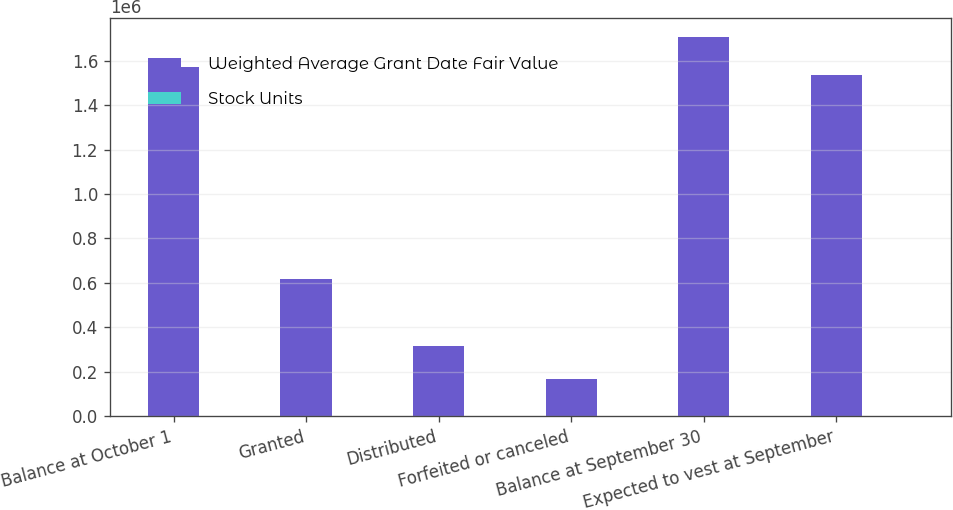Convert chart. <chart><loc_0><loc_0><loc_500><loc_500><stacked_bar_chart><ecel><fcel>Balance at October 1<fcel>Granted<fcel>Distributed<fcel>Forfeited or canceled<fcel>Balance at September 30<fcel>Expected to vest at September<nl><fcel>Weighted Average Grant Date Fair Value<fcel>1.57033e+06<fcel>618679<fcel>316839<fcel>165211<fcel>1.70696e+06<fcel>1.53626e+06<nl><fcel>Stock Units<fcel>69.35<fcel>62.96<fcel>60.32<fcel>62.58<fcel>69.36<fcel>69.36<nl></chart> 